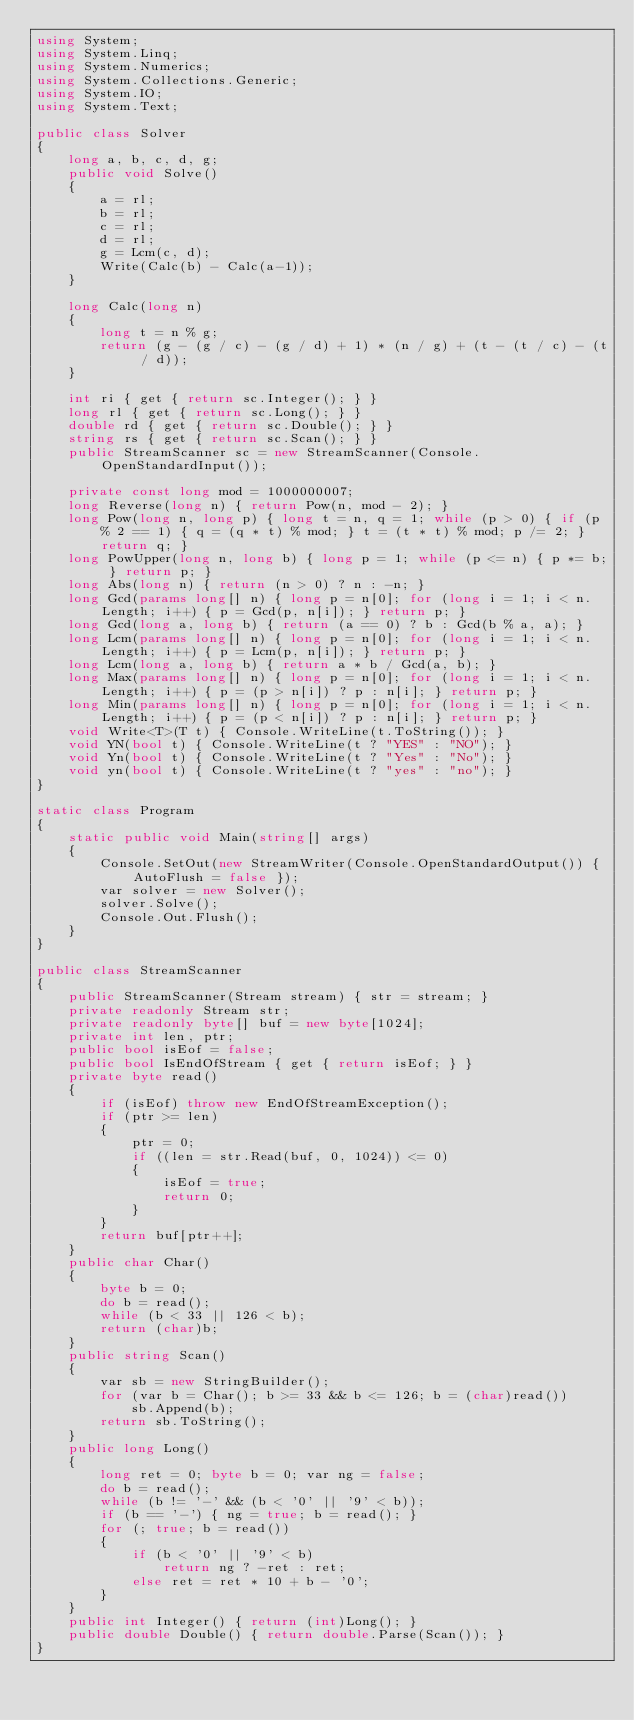Convert code to text. <code><loc_0><loc_0><loc_500><loc_500><_C#_>using System;
using System.Linq;
using System.Numerics;
using System.Collections.Generic;
using System.IO;
using System.Text;

public class Solver
{
    long a, b, c, d, g;
    public void Solve()
    {
        a = rl;
        b = rl;
        c = rl;
        d = rl;
        g = Lcm(c, d);
        Write(Calc(b) - Calc(a-1));
    }

    long Calc(long n)
    {
        long t = n % g;
        return (g - (g / c) - (g / d) + 1) * (n / g) + (t - (t / c) - (t / d));
    }

    int ri { get { return sc.Integer(); } }
    long rl { get { return sc.Long(); } }
    double rd { get { return sc.Double(); } }
    string rs { get { return sc.Scan(); } }
    public StreamScanner sc = new StreamScanner(Console.OpenStandardInput());

    private const long mod = 1000000007;
    long Reverse(long n) { return Pow(n, mod - 2); }
    long Pow(long n, long p) { long t = n, q = 1; while (p > 0) { if (p % 2 == 1) { q = (q * t) % mod; } t = (t * t) % mod; p /= 2; } return q; }
    long PowUpper(long n, long b) { long p = 1; while (p <= n) { p *= b; } return p; }
    long Abs(long n) { return (n > 0) ? n : -n; }
    long Gcd(params long[] n) { long p = n[0]; for (long i = 1; i < n.Length; i++) { p = Gcd(p, n[i]); } return p; }
    long Gcd(long a, long b) { return (a == 0) ? b : Gcd(b % a, a); }
    long Lcm(params long[] n) { long p = n[0]; for (long i = 1; i < n.Length; i++) { p = Lcm(p, n[i]); } return p; }
    long Lcm(long a, long b) { return a * b / Gcd(a, b); }
    long Max(params long[] n) { long p = n[0]; for (long i = 1; i < n.Length; i++) { p = (p > n[i]) ? p : n[i]; } return p; }
    long Min(params long[] n) { long p = n[0]; for (long i = 1; i < n.Length; i++) { p = (p < n[i]) ? p : n[i]; } return p; }
    void Write<T>(T t) { Console.WriteLine(t.ToString()); }
    void YN(bool t) { Console.WriteLine(t ? "YES" : "NO"); }
    void Yn(bool t) { Console.WriteLine(t ? "Yes" : "No"); }
    void yn(bool t) { Console.WriteLine(t ? "yes" : "no"); }
}

static class Program
{
    static public void Main(string[] args)
    {
        Console.SetOut(new StreamWriter(Console.OpenStandardOutput()) { AutoFlush = false });
        var solver = new Solver();
        solver.Solve();
        Console.Out.Flush();
    }
}

public class StreamScanner
{
    public StreamScanner(Stream stream) { str = stream; }
    private readonly Stream str;
    private readonly byte[] buf = new byte[1024];
    private int len, ptr;
    public bool isEof = false;
    public bool IsEndOfStream { get { return isEof; } }
    private byte read()
    {
        if (isEof) throw new EndOfStreamException();
        if (ptr >= len)
        {
            ptr = 0;
            if ((len = str.Read(buf, 0, 1024)) <= 0)
            {
                isEof = true;
                return 0;
            }
        }
        return buf[ptr++];
    }
    public char Char()
    {
        byte b = 0;
        do b = read();
        while (b < 33 || 126 < b);
        return (char)b;
    }
    public string Scan()
    {
        var sb = new StringBuilder();
        for (var b = Char(); b >= 33 && b <= 126; b = (char)read())
            sb.Append(b);
        return sb.ToString();
    }
    public long Long()
    {
        long ret = 0; byte b = 0; var ng = false;
        do b = read();
        while (b != '-' && (b < '0' || '9' < b));
        if (b == '-') { ng = true; b = read(); }
        for (; true; b = read())
        {
            if (b < '0' || '9' < b)
                return ng ? -ret : ret;
            else ret = ret * 10 + b - '0';
        }
    }
    public int Integer() { return (int)Long(); }
    public double Double() { return double.Parse(Scan()); }
}
</code> 